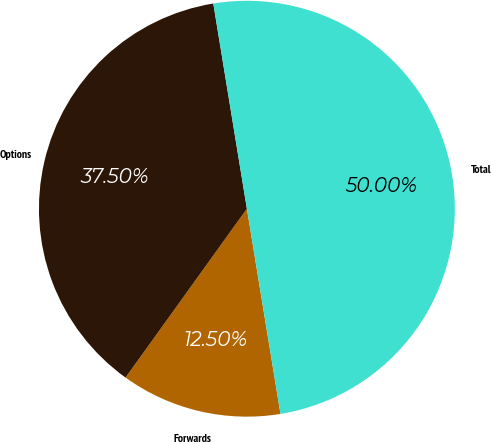<chart> <loc_0><loc_0><loc_500><loc_500><pie_chart><fcel>Forwards<fcel>Options<fcel>Total<nl><fcel>12.5%<fcel>37.5%<fcel>50.0%<nl></chart> 